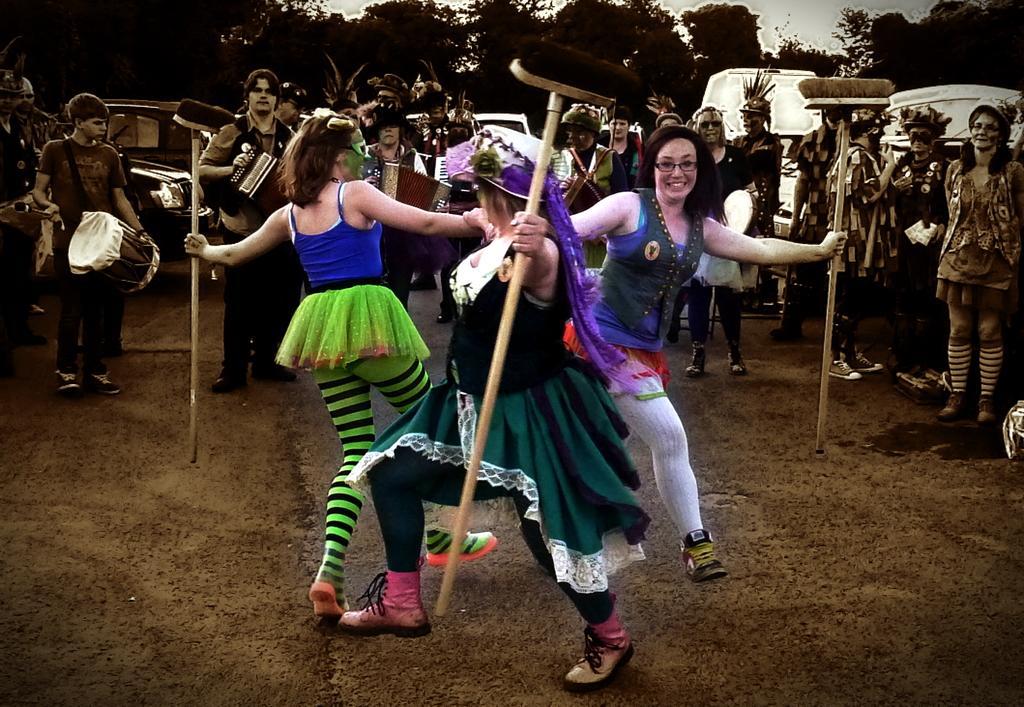How would you summarize this image in a sentence or two? In this picture we can see three woman dancing in front and and holding some brushes in the background we can see some group of people playing musical instruments, some people wore costumes and in the background we can see trees and sky. 